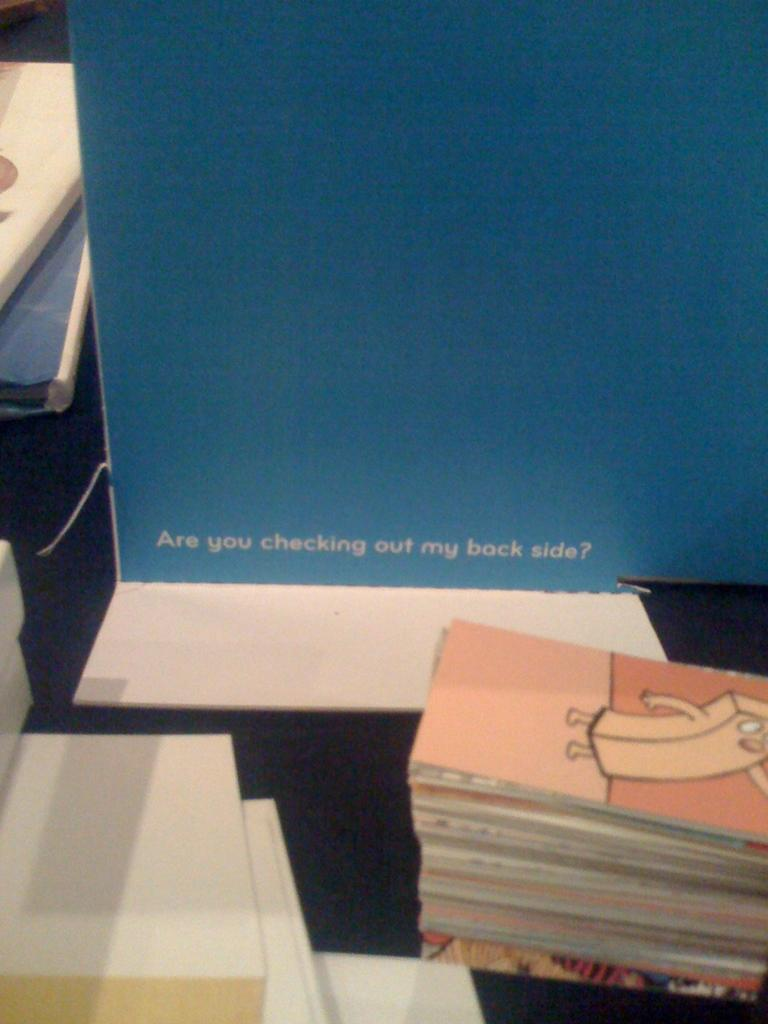<image>
Provide a brief description of the given image. a blue sign reads Are you checking out my back side 